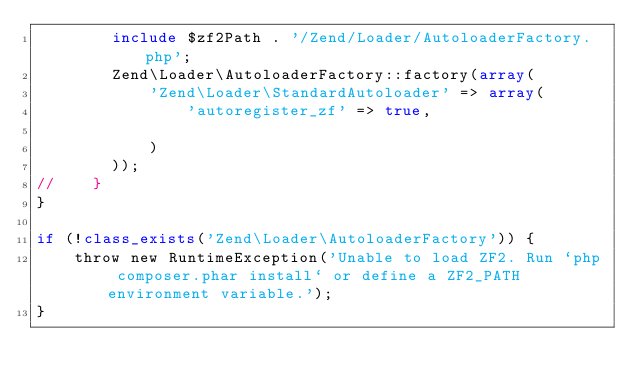<code> <loc_0><loc_0><loc_500><loc_500><_PHP_>        include $zf2Path . '/Zend/Loader/AutoloaderFactory.php';
        Zend\Loader\AutoloaderFactory::factory(array(
            'Zend\Loader\StandardAutoloader' => array(
                'autoregister_zf' => true,
                
            )
        ));
//    }
}

if (!class_exists('Zend\Loader\AutoloaderFactory')) {
    throw new RuntimeException('Unable to load ZF2. Run `php composer.phar install` or define a ZF2_PATH environment variable.');
}
</code> 